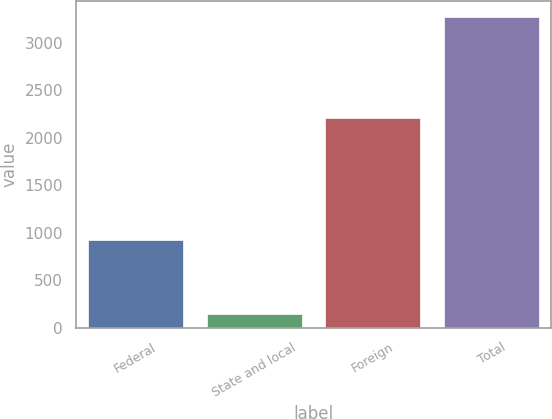Convert chart to OTSL. <chart><loc_0><loc_0><loc_500><loc_500><bar_chart><fcel>Federal<fcel>State and local<fcel>Foreign<fcel>Total<nl><fcel>921<fcel>146<fcel>2206<fcel>3273<nl></chart> 